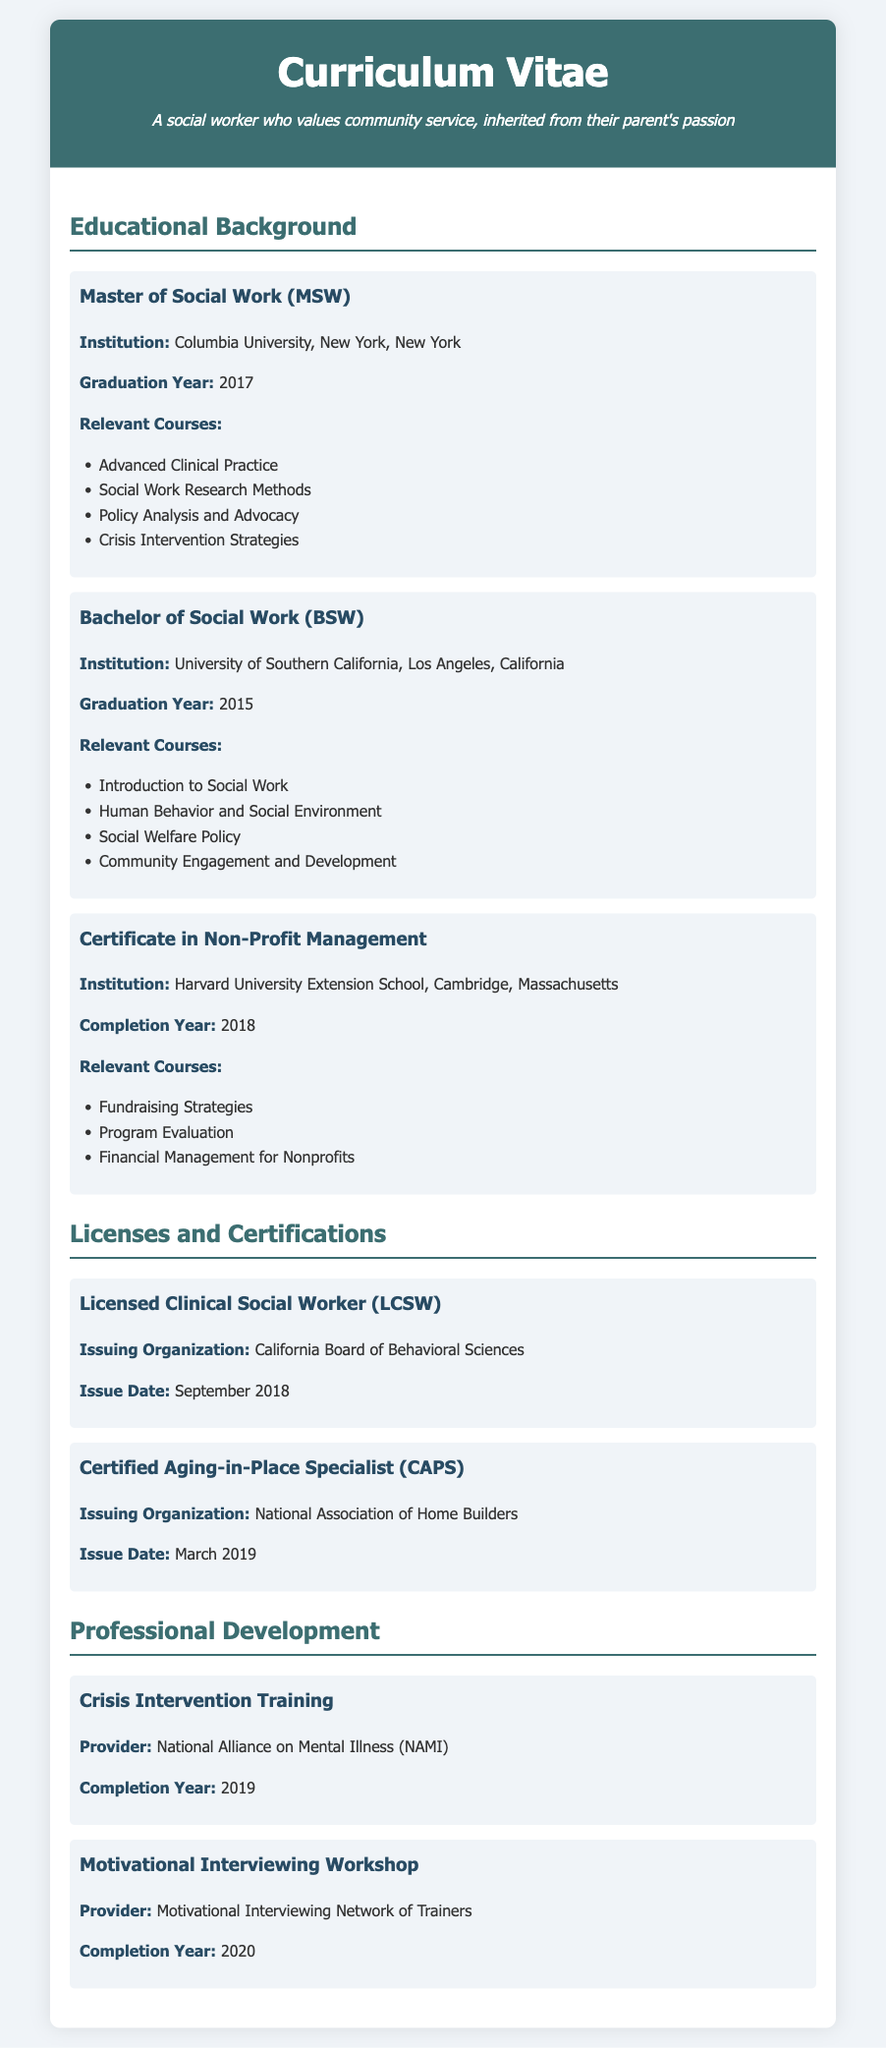what degree was earned at Columbia University? The document lists the Master of Social Work (MSW) as the degree obtained from Columbia University.
Answer: Master of Social Work (MSW) what year did the individual graduate with a BSW? The document specifies that the individual graduated with a Bachelor of Social Work in the year 2015.
Answer: 2015 which certification was issued by the California Board of Behavioral Sciences? The document indicates that the Licensed Clinical Social Worker (LCSW) certification was issued by this organization.
Answer: Licensed Clinical Social Worker (LCSW) name one relevant course taken in the Master of Social Work program. One of the relevant courses listed is Advanced Clinical Practice as part of the MSW program.
Answer: Advanced Clinical Practice how many relevant courses are listed under the Certificate in Non-Profit Management? The document presents three relevant courses for the Certificate in Non-Profit Management, indicating the total number.
Answer: 3 which institution awarded the Certificate in Non-Profit Management? The certificate was earned from Harvard University Extension School.
Answer: Harvard University Extension School what is the completion year for the Motivational Interviewing Workshop? The document indicates that this workshop was completed in the year 2020.
Answer: 2020 which degree was obtained from the University of Southern California? The document states that the individual earned a Bachelor of Social Work (BSW) from this university.
Answer: Bachelor of Social Work (BSW) 